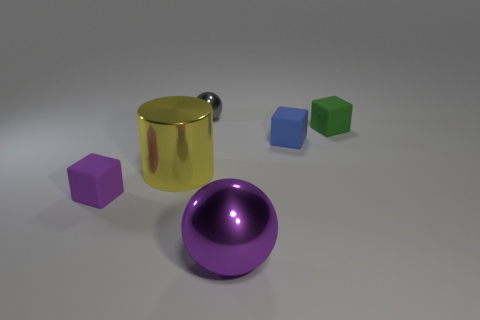Is there anything else that has the same material as the large cylinder?
Ensure brevity in your answer.  Yes. What shape is the yellow thing that is the same size as the purple ball?
Make the answer very short. Cylinder. What is the color of the small thing behind the tiny rubber cube behind the blue cube that is behind the big yellow thing?
Ensure brevity in your answer.  Gray. How many things are rubber objects that are behind the small purple rubber thing or matte objects?
Give a very brief answer. 3. There is a purple sphere that is the same size as the yellow shiny cylinder; what material is it?
Offer a very short reply. Metal. The large object that is in front of the big shiny thing that is behind the tiny rubber cube that is left of the yellow shiny thing is made of what material?
Ensure brevity in your answer.  Metal. The big ball is what color?
Your answer should be compact. Purple. What number of large things are either yellow shiny cylinders or red metal cylinders?
Provide a succinct answer. 1. What material is the block that is the same color as the large shiny ball?
Keep it short and to the point. Rubber. Do the purple thing that is right of the tiny purple block and the tiny cube that is on the left side of the small gray metallic sphere have the same material?
Offer a terse response. No. 